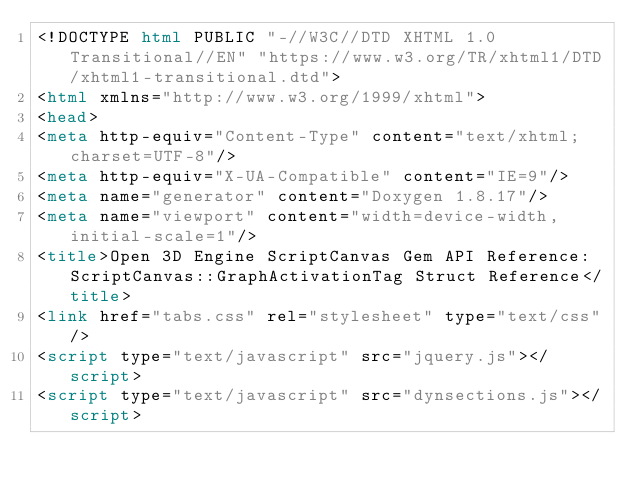Convert code to text. <code><loc_0><loc_0><loc_500><loc_500><_HTML_><!DOCTYPE html PUBLIC "-//W3C//DTD XHTML 1.0 Transitional//EN" "https://www.w3.org/TR/xhtml1/DTD/xhtml1-transitional.dtd">
<html xmlns="http://www.w3.org/1999/xhtml">
<head>
<meta http-equiv="Content-Type" content="text/xhtml;charset=UTF-8"/>
<meta http-equiv="X-UA-Compatible" content="IE=9"/>
<meta name="generator" content="Doxygen 1.8.17"/>
<meta name="viewport" content="width=device-width, initial-scale=1"/>
<title>Open 3D Engine ScriptCanvas Gem API Reference: ScriptCanvas::GraphActivationTag Struct Reference</title>
<link href="tabs.css" rel="stylesheet" type="text/css"/>
<script type="text/javascript" src="jquery.js"></script>
<script type="text/javascript" src="dynsections.js"></script></code> 